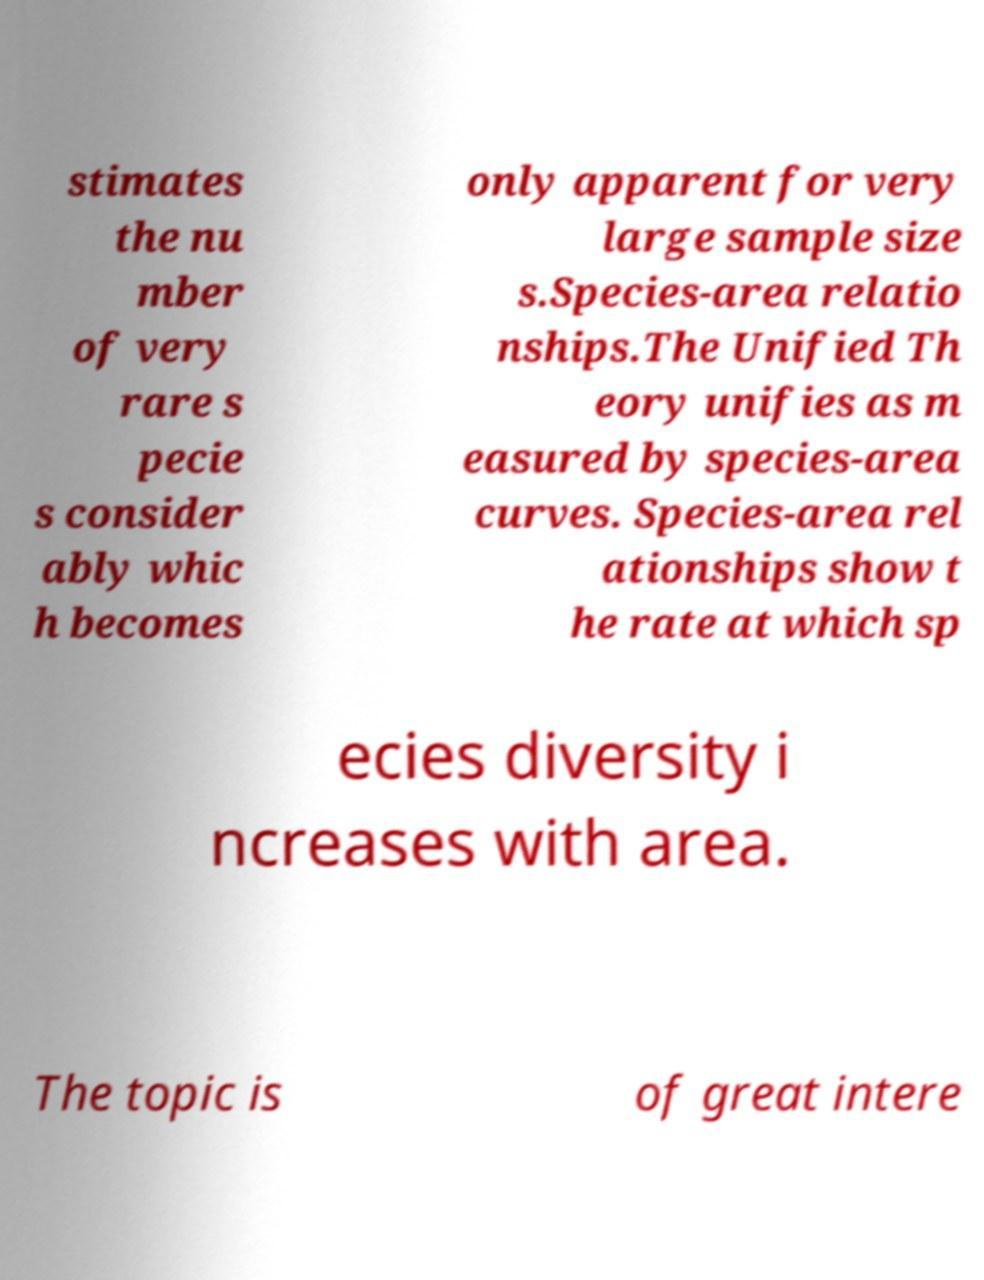Could you assist in decoding the text presented in this image and type it out clearly? stimates the nu mber of very rare s pecie s consider ably whic h becomes only apparent for very large sample size s.Species-area relatio nships.The Unified Th eory unifies as m easured by species-area curves. Species-area rel ationships show t he rate at which sp ecies diversity i ncreases with area. The topic is of great intere 